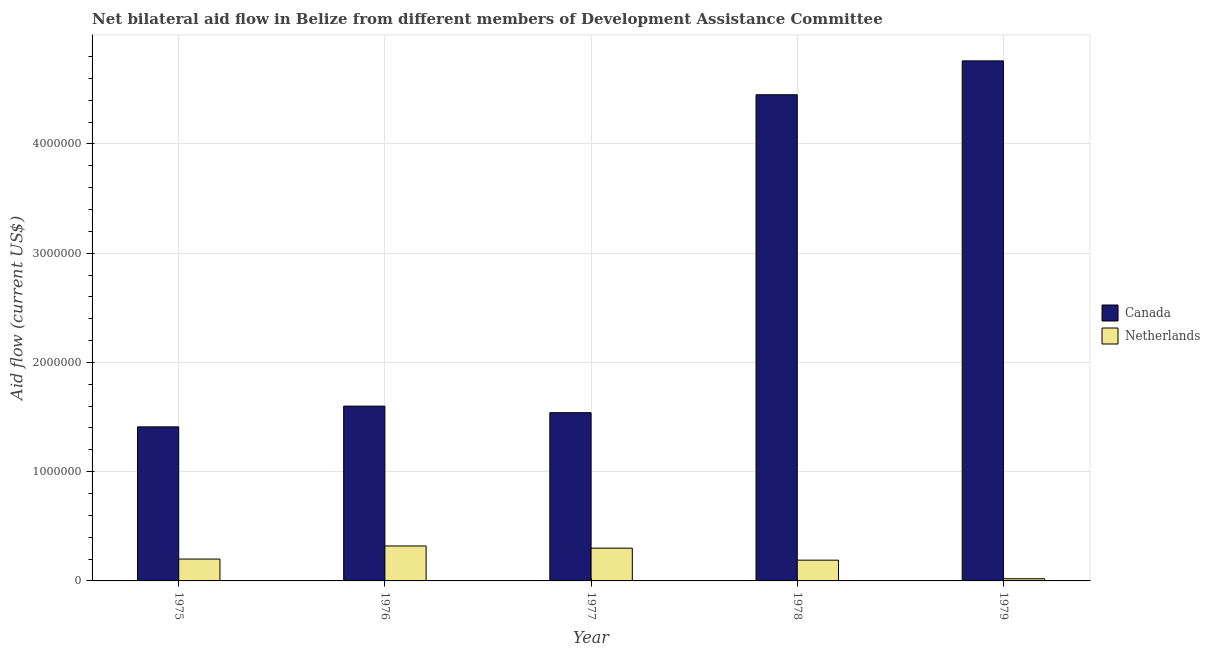How many different coloured bars are there?
Provide a short and direct response. 2. How many groups of bars are there?
Offer a very short reply. 5. Are the number of bars per tick equal to the number of legend labels?
Ensure brevity in your answer.  Yes. Are the number of bars on each tick of the X-axis equal?
Give a very brief answer. Yes. How many bars are there on the 2nd tick from the right?
Provide a succinct answer. 2. What is the label of the 4th group of bars from the left?
Ensure brevity in your answer.  1978. In how many cases, is the number of bars for a given year not equal to the number of legend labels?
Offer a terse response. 0. What is the amount of aid given by canada in 1975?
Your response must be concise. 1.41e+06. Across all years, what is the maximum amount of aid given by canada?
Provide a succinct answer. 4.76e+06. Across all years, what is the minimum amount of aid given by netherlands?
Ensure brevity in your answer.  2.00e+04. In which year was the amount of aid given by canada maximum?
Ensure brevity in your answer.  1979. In which year was the amount of aid given by netherlands minimum?
Your response must be concise. 1979. What is the total amount of aid given by canada in the graph?
Offer a very short reply. 1.38e+07. What is the difference between the amount of aid given by canada in 1975 and that in 1979?
Provide a succinct answer. -3.35e+06. What is the difference between the amount of aid given by canada in 1978 and the amount of aid given by netherlands in 1977?
Keep it short and to the point. 2.91e+06. What is the average amount of aid given by netherlands per year?
Offer a terse response. 2.06e+05. What is the ratio of the amount of aid given by netherlands in 1976 to that in 1978?
Ensure brevity in your answer.  1.68. Is the difference between the amount of aid given by netherlands in 1976 and 1978 greater than the difference between the amount of aid given by canada in 1976 and 1978?
Offer a very short reply. No. What is the difference between the highest and the second highest amount of aid given by netherlands?
Offer a very short reply. 2.00e+04. What is the difference between the highest and the lowest amount of aid given by netherlands?
Offer a terse response. 3.00e+05. What is the difference between two consecutive major ticks on the Y-axis?
Offer a very short reply. 1.00e+06. What is the title of the graph?
Offer a very short reply. Net bilateral aid flow in Belize from different members of Development Assistance Committee. Does "Canada" appear as one of the legend labels in the graph?
Provide a short and direct response. Yes. What is the label or title of the X-axis?
Your answer should be compact. Year. What is the label or title of the Y-axis?
Provide a succinct answer. Aid flow (current US$). What is the Aid flow (current US$) of Canada in 1975?
Provide a succinct answer. 1.41e+06. What is the Aid flow (current US$) of Netherlands in 1975?
Keep it short and to the point. 2.00e+05. What is the Aid flow (current US$) in Canada in 1976?
Your response must be concise. 1.60e+06. What is the Aid flow (current US$) of Netherlands in 1976?
Your answer should be compact. 3.20e+05. What is the Aid flow (current US$) in Canada in 1977?
Offer a terse response. 1.54e+06. What is the Aid flow (current US$) of Canada in 1978?
Offer a very short reply. 4.45e+06. What is the Aid flow (current US$) in Canada in 1979?
Keep it short and to the point. 4.76e+06. Across all years, what is the maximum Aid flow (current US$) of Canada?
Give a very brief answer. 4.76e+06. Across all years, what is the maximum Aid flow (current US$) of Netherlands?
Offer a terse response. 3.20e+05. Across all years, what is the minimum Aid flow (current US$) in Canada?
Provide a succinct answer. 1.41e+06. Across all years, what is the minimum Aid flow (current US$) of Netherlands?
Offer a very short reply. 2.00e+04. What is the total Aid flow (current US$) of Canada in the graph?
Give a very brief answer. 1.38e+07. What is the total Aid flow (current US$) in Netherlands in the graph?
Your response must be concise. 1.03e+06. What is the difference between the Aid flow (current US$) in Canada in 1975 and that in 1977?
Ensure brevity in your answer.  -1.30e+05. What is the difference between the Aid flow (current US$) in Netherlands in 1975 and that in 1977?
Make the answer very short. -1.00e+05. What is the difference between the Aid flow (current US$) in Canada in 1975 and that in 1978?
Ensure brevity in your answer.  -3.04e+06. What is the difference between the Aid flow (current US$) in Netherlands in 1975 and that in 1978?
Ensure brevity in your answer.  10000. What is the difference between the Aid flow (current US$) of Canada in 1975 and that in 1979?
Ensure brevity in your answer.  -3.35e+06. What is the difference between the Aid flow (current US$) in Netherlands in 1976 and that in 1977?
Ensure brevity in your answer.  2.00e+04. What is the difference between the Aid flow (current US$) of Canada in 1976 and that in 1978?
Keep it short and to the point. -2.85e+06. What is the difference between the Aid flow (current US$) of Canada in 1976 and that in 1979?
Provide a succinct answer. -3.16e+06. What is the difference between the Aid flow (current US$) in Canada in 1977 and that in 1978?
Make the answer very short. -2.91e+06. What is the difference between the Aid flow (current US$) of Netherlands in 1977 and that in 1978?
Provide a succinct answer. 1.10e+05. What is the difference between the Aid flow (current US$) in Canada in 1977 and that in 1979?
Give a very brief answer. -3.22e+06. What is the difference between the Aid flow (current US$) in Netherlands in 1977 and that in 1979?
Give a very brief answer. 2.80e+05. What is the difference between the Aid flow (current US$) of Canada in 1978 and that in 1979?
Give a very brief answer. -3.10e+05. What is the difference between the Aid flow (current US$) of Netherlands in 1978 and that in 1979?
Keep it short and to the point. 1.70e+05. What is the difference between the Aid flow (current US$) in Canada in 1975 and the Aid flow (current US$) in Netherlands in 1976?
Offer a terse response. 1.09e+06. What is the difference between the Aid flow (current US$) of Canada in 1975 and the Aid flow (current US$) of Netherlands in 1977?
Your response must be concise. 1.11e+06. What is the difference between the Aid flow (current US$) in Canada in 1975 and the Aid flow (current US$) in Netherlands in 1978?
Offer a very short reply. 1.22e+06. What is the difference between the Aid flow (current US$) of Canada in 1975 and the Aid flow (current US$) of Netherlands in 1979?
Give a very brief answer. 1.39e+06. What is the difference between the Aid flow (current US$) in Canada in 1976 and the Aid flow (current US$) in Netherlands in 1977?
Your answer should be very brief. 1.30e+06. What is the difference between the Aid flow (current US$) in Canada in 1976 and the Aid flow (current US$) in Netherlands in 1978?
Give a very brief answer. 1.41e+06. What is the difference between the Aid flow (current US$) of Canada in 1976 and the Aid flow (current US$) of Netherlands in 1979?
Keep it short and to the point. 1.58e+06. What is the difference between the Aid flow (current US$) in Canada in 1977 and the Aid flow (current US$) in Netherlands in 1978?
Your answer should be compact. 1.35e+06. What is the difference between the Aid flow (current US$) of Canada in 1977 and the Aid flow (current US$) of Netherlands in 1979?
Your response must be concise. 1.52e+06. What is the difference between the Aid flow (current US$) of Canada in 1978 and the Aid flow (current US$) of Netherlands in 1979?
Ensure brevity in your answer.  4.43e+06. What is the average Aid flow (current US$) in Canada per year?
Your answer should be compact. 2.75e+06. What is the average Aid flow (current US$) in Netherlands per year?
Provide a succinct answer. 2.06e+05. In the year 1975, what is the difference between the Aid flow (current US$) in Canada and Aid flow (current US$) in Netherlands?
Your response must be concise. 1.21e+06. In the year 1976, what is the difference between the Aid flow (current US$) of Canada and Aid flow (current US$) of Netherlands?
Your answer should be compact. 1.28e+06. In the year 1977, what is the difference between the Aid flow (current US$) in Canada and Aid flow (current US$) in Netherlands?
Your answer should be very brief. 1.24e+06. In the year 1978, what is the difference between the Aid flow (current US$) in Canada and Aid flow (current US$) in Netherlands?
Give a very brief answer. 4.26e+06. In the year 1979, what is the difference between the Aid flow (current US$) of Canada and Aid flow (current US$) of Netherlands?
Keep it short and to the point. 4.74e+06. What is the ratio of the Aid flow (current US$) of Canada in 1975 to that in 1976?
Keep it short and to the point. 0.88. What is the ratio of the Aid flow (current US$) of Netherlands in 1975 to that in 1976?
Provide a short and direct response. 0.62. What is the ratio of the Aid flow (current US$) of Canada in 1975 to that in 1977?
Your response must be concise. 0.92. What is the ratio of the Aid flow (current US$) in Netherlands in 1975 to that in 1977?
Keep it short and to the point. 0.67. What is the ratio of the Aid flow (current US$) of Canada in 1975 to that in 1978?
Your response must be concise. 0.32. What is the ratio of the Aid flow (current US$) of Netherlands in 1975 to that in 1978?
Offer a terse response. 1.05. What is the ratio of the Aid flow (current US$) in Canada in 1975 to that in 1979?
Your answer should be compact. 0.3. What is the ratio of the Aid flow (current US$) in Canada in 1976 to that in 1977?
Your answer should be very brief. 1.04. What is the ratio of the Aid flow (current US$) of Netherlands in 1976 to that in 1977?
Give a very brief answer. 1.07. What is the ratio of the Aid flow (current US$) of Canada in 1976 to that in 1978?
Offer a very short reply. 0.36. What is the ratio of the Aid flow (current US$) of Netherlands in 1976 to that in 1978?
Provide a short and direct response. 1.68. What is the ratio of the Aid flow (current US$) of Canada in 1976 to that in 1979?
Offer a terse response. 0.34. What is the ratio of the Aid flow (current US$) of Netherlands in 1976 to that in 1979?
Give a very brief answer. 16. What is the ratio of the Aid flow (current US$) of Canada in 1977 to that in 1978?
Your answer should be compact. 0.35. What is the ratio of the Aid flow (current US$) of Netherlands in 1977 to that in 1978?
Offer a terse response. 1.58. What is the ratio of the Aid flow (current US$) of Canada in 1977 to that in 1979?
Your answer should be compact. 0.32. What is the ratio of the Aid flow (current US$) in Netherlands in 1977 to that in 1979?
Ensure brevity in your answer.  15. What is the ratio of the Aid flow (current US$) of Canada in 1978 to that in 1979?
Offer a very short reply. 0.93. What is the ratio of the Aid flow (current US$) in Netherlands in 1978 to that in 1979?
Offer a very short reply. 9.5. What is the difference between the highest and the second highest Aid flow (current US$) of Canada?
Offer a terse response. 3.10e+05. What is the difference between the highest and the lowest Aid flow (current US$) in Canada?
Make the answer very short. 3.35e+06. What is the difference between the highest and the lowest Aid flow (current US$) of Netherlands?
Your answer should be compact. 3.00e+05. 